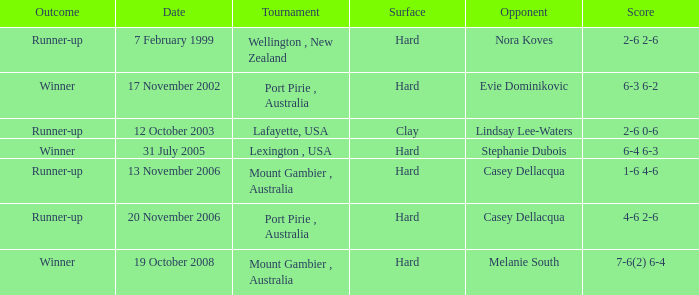Which Opponent is on 17 november 2002? Evie Dominikovic. 